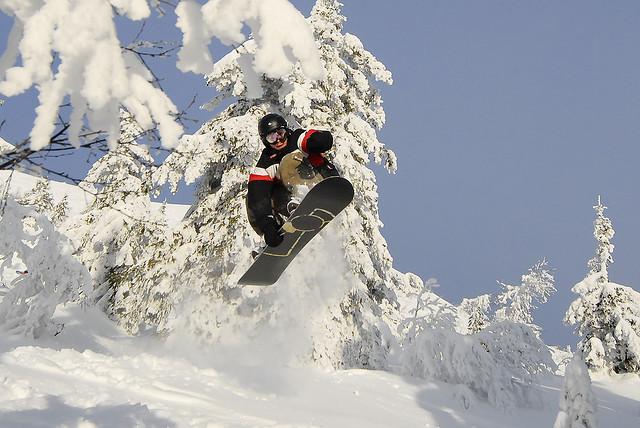What sport is the person participating in?
Quick response, please. Snowboarding. What is this guy participating in?
Write a very short answer. Snowboarding. What is the approximate temperature there?
Be succinct. 0. What's on the trees?
Short answer required. Snow. 